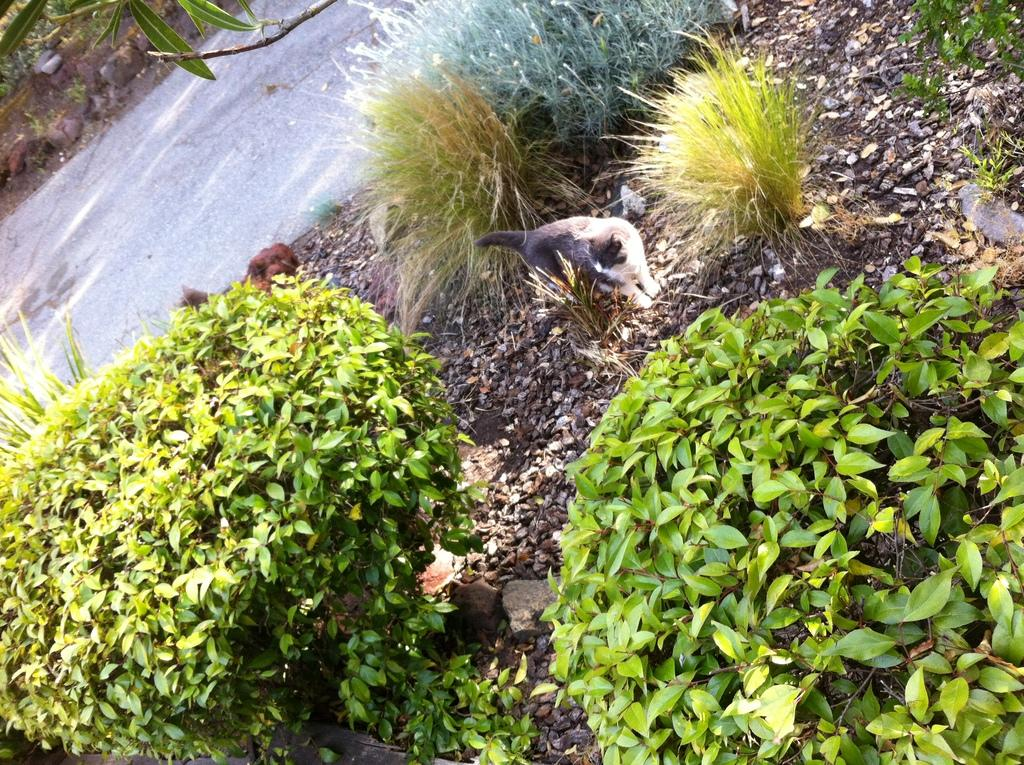What animals are present in the image? There is a cat and a dog in the image. What are the positions of the cat and dog in the image? The cat and dog are standing in the image. What type of ground surface is visible in the image? There are stones in the image. What type of vegetation is present in the image? There are plants in the image. What can be seen in the background of the image? There is a road visible in the background of the image. Can you see any snakes playing in the waves in the image? There are no snakes or waves present in the image. 